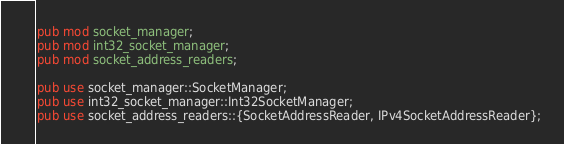<code> <loc_0><loc_0><loc_500><loc_500><_Rust_>pub mod socket_manager;
pub mod int32_socket_manager;
pub mod socket_address_readers;

pub use socket_manager::SocketManager;
pub use int32_socket_manager::Int32SocketManager;
pub use socket_address_readers::{SocketAddressReader, IPv4SocketAddressReader};
</code> 